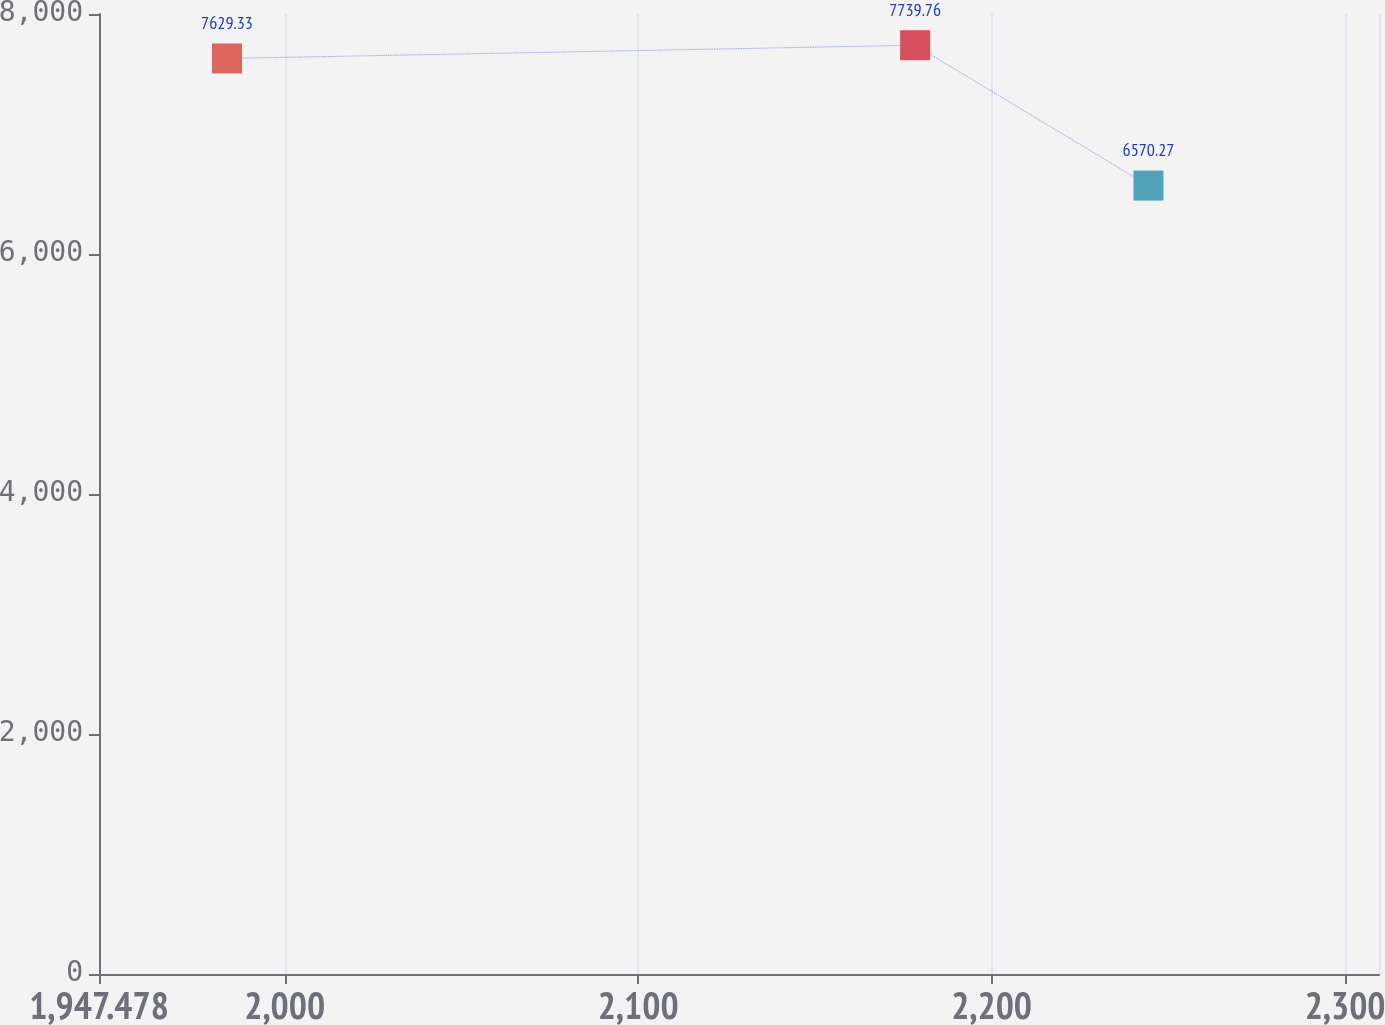Convert chart to OTSL. <chart><loc_0><loc_0><loc_500><loc_500><line_chart><ecel><fcel>$ 10,711<nl><fcel>1983.69<fcel>7629.33<nl><fcel>2178.37<fcel>7739.76<nl><fcel>2244.37<fcel>6570.27<nl><fcel>2345.81<fcel>7518.9<nl></chart> 